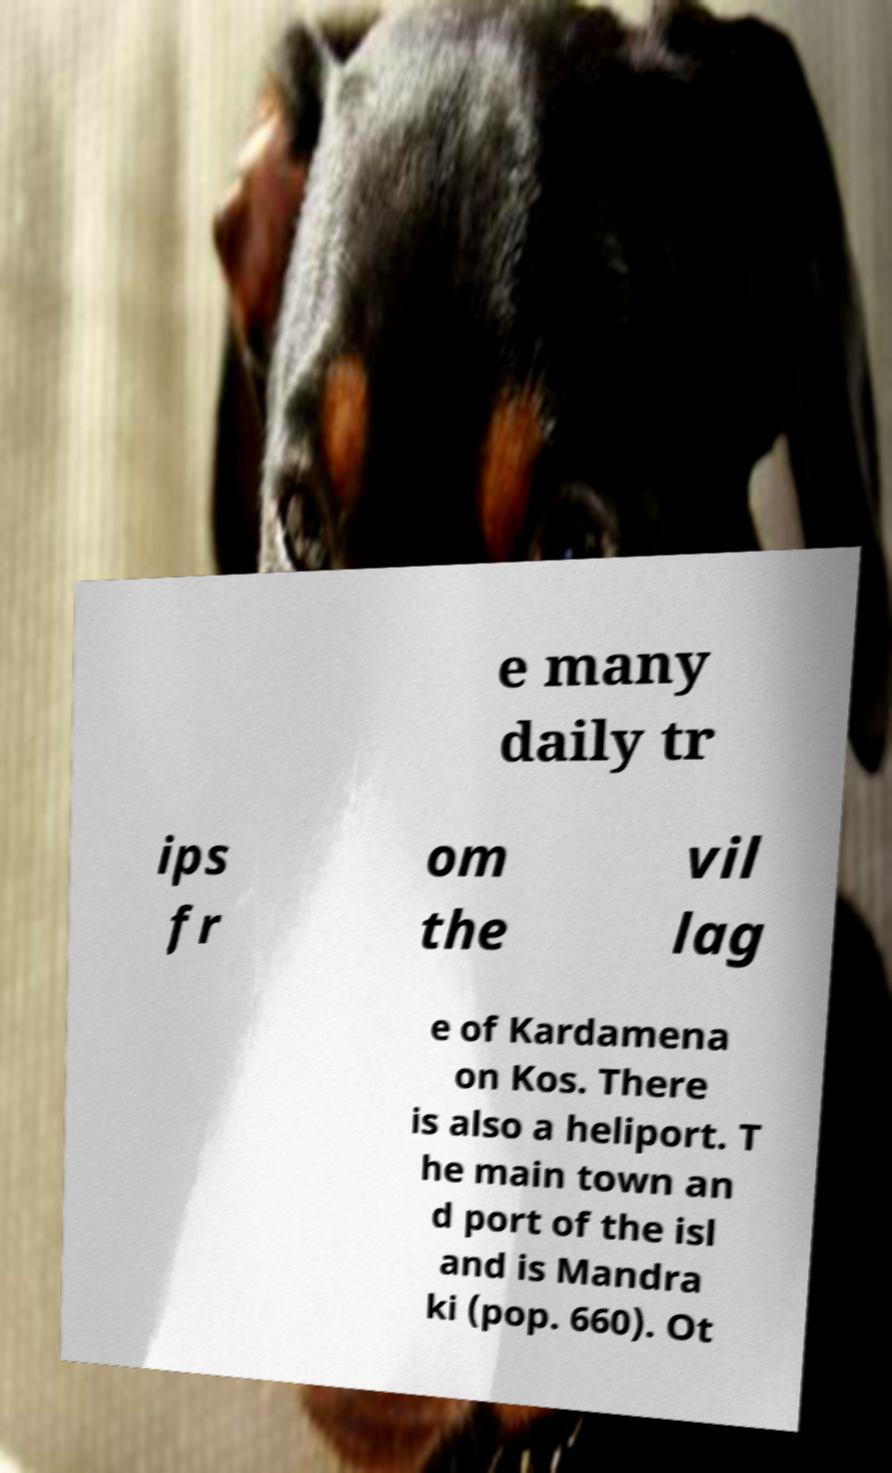Please read and relay the text visible in this image. What does it say? e many daily tr ips fr om the vil lag e of Kardamena on Kos. There is also a heliport. T he main town an d port of the isl and is Mandra ki (pop. 660). Ot 